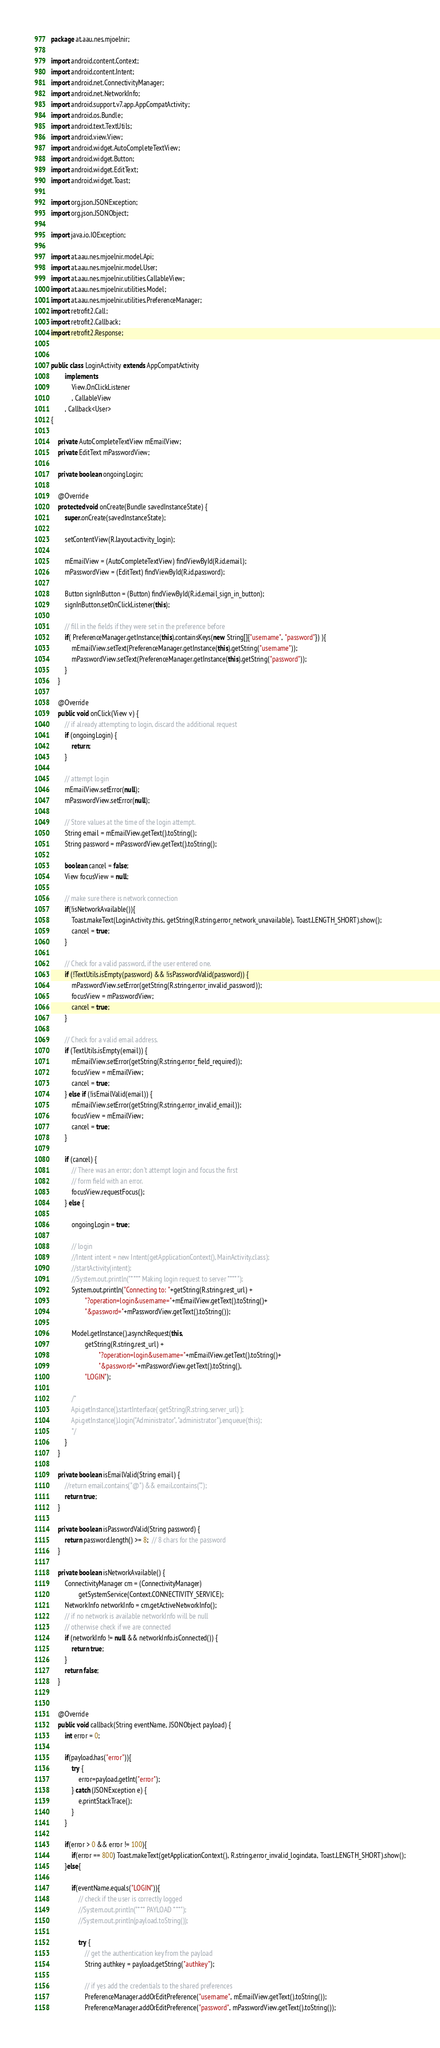<code> <loc_0><loc_0><loc_500><loc_500><_Java_>package at.aau.nes.mjoelnir;

import android.content.Context;
import android.content.Intent;
import android.net.ConnectivityManager;
import android.net.NetworkInfo;
import android.support.v7.app.AppCompatActivity;
import android.os.Bundle;
import android.text.TextUtils;
import android.view.View;
import android.widget.AutoCompleteTextView;
import android.widget.Button;
import android.widget.EditText;
import android.widget.Toast;

import org.json.JSONException;
import org.json.JSONObject;

import java.io.IOException;

import at.aau.nes.mjoelnir.model.Api;
import at.aau.nes.mjoelnir.model.User;
import at.aau.nes.mjoelnir.utilities.CallableView;
import at.aau.nes.mjoelnir.utilities.Model;
import at.aau.nes.mjoelnir.utilities.PreferenceManager;
import retrofit2.Call;
import retrofit2.Callback;
import retrofit2.Response;


public class LoginActivity extends AppCompatActivity
        implements
            View.OnClickListener
            , CallableView
        , Callback<User>
{

    private AutoCompleteTextView mEmailView;
    private EditText mPasswordView;

    private boolean ongoingLogin;

    @Override
    protected void onCreate(Bundle savedInstanceState) {
        super.onCreate(savedInstanceState);

        setContentView(R.layout.activity_login);

        mEmailView = (AutoCompleteTextView) findViewById(R.id.email);
        mPasswordView = (EditText) findViewById(R.id.password);

        Button signInButton = (Button) findViewById(R.id.email_sign_in_button);
        signInButton.setOnClickListener(this);

        // fill in the fields if they were set in the preference before
        if( PreferenceManager.getInstance(this).containsKeys(new String[]{"username", "password"}) ){
            mEmailView.setText(PreferenceManager.getInstance(this).getString("username"));
            mPasswordView.setText(PreferenceManager.getInstance(this).getString("password"));
        }
    }

    @Override
    public void onClick(View v) {
        // if already attempting to login, discard the additional request
        if (ongoingLogin) {
            return;
        }

        // attempt login
        mEmailView.setError(null);
        mPasswordView.setError(null);

        // Store values at the time of the login attempt.
        String email = mEmailView.getText().toString();
        String password = mPasswordView.getText().toString();

        boolean cancel = false;
        View focusView = null;

        // make sure there is network connection
        if(!isNetworkAvailable()){
            Toast.makeText(LoginActivity.this, getString(R.string.error_network_unavailable), Toast.LENGTH_SHORT).show();
            cancel = true;
        }

        // Check for a valid password, if the user entered one.
        if (!TextUtils.isEmpty(password) && !isPasswordValid(password)) {
            mPasswordView.setError(getString(R.string.error_invalid_password));
            focusView = mPasswordView;
            cancel = true;
        }

        // Check for a valid email address.
        if (TextUtils.isEmpty(email)) {
            mEmailView.setError(getString(R.string.error_field_required));
            focusView = mEmailView;
            cancel = true;
        } else if (!isEmailValid(email)) {
            mEmailView.setError(getString(R.string.error_invalid_email));
            focusView = mEmailView;
            cancel = true;
        }

        if (cancel) {
            // There was an error; don't attempt login and focus the first
            // form field with an error.
            focusView.requestFocus();
        } else {

            ongoingLogin = true;

            // login
            //Intent intent = new Intent(getApplicationContext(), MainActivity.class);
            //startActivity(intent);
            //System.out.println("**** Making login request to server ****");
            System.out.println("Connecting to: "+getString(R.string.rest_url) +
                    "?operation=login&username="+mEmailView.getText().toString()+
                    "&password="+mPasswordView.getText().toString());

            Model.getInstance().asynchRequest(this,
                    getString(R.string.rest_url) +
                            "?operation=login&username="+mEmailView.getText().toString()+
                            "&password="+mPasswordView.getText().toString(),
                    "LOGIN");

            /*
            Api.getInstance().startInterface( getString(R.string.server_url) );
            Api.getInstance().login("Administrator", "administrator").enqueue(this);
            */
        }
    }

    private boolean isEmailValid(String email) {
        //return email.contains("@") && email.contains(".");
        return true;
    }

    private boolean isPasswordValid(String password) {
        return password.length() >= 8;  // 8 chars for the password
    }

    private boolean isNetworkAvailable() {
        ConnectivityManager cm = (ConnectivityManager)
                getSystemService(Context.CONNECTIVITY_SERVICE);
        NetworkInfo networkInfo = cm.getActiveNetworkInfo();
        // if no network is available networkInfo will be null
        // otherwise check if we are connected
        if (networkInfo != null && networkInfo.isConnected()) {
            return true;
        }
        return false;
    }


    @Override
    public void callback(String eventName, JSONObject payload) {
        int error = 0;

        if(payload.has("error")){
            try {
                error=payload.getInt("error");
            } catch (JSONException e) {
                e.printStackTrace();
            }
        }

        if(error > 0 && error != 100){
            if(error == 800) Toast.makeText(getApplicationContext(), R.string.error_invalid_logindata, Toast.LENGTH_SHORT).show();
        }else{

            if(eventName.equals("LOGIN")){
                // check if the user is correctly logged
                //System.out.println("*** PAYLOAD ***");
                //System.out.println(payload.toString());

                try {
                    // get the authentication key from the payload
                    String authkey = payload.getString("authkey");

                    // if yes add the credentials to the shared preferences
                    PreferenceManager.addOrEditPreference("username", mEmailView.getText().toString());
                    PreferenceManager.addOrEditPreference("password", mPasswordView.getText().toString());</code> 